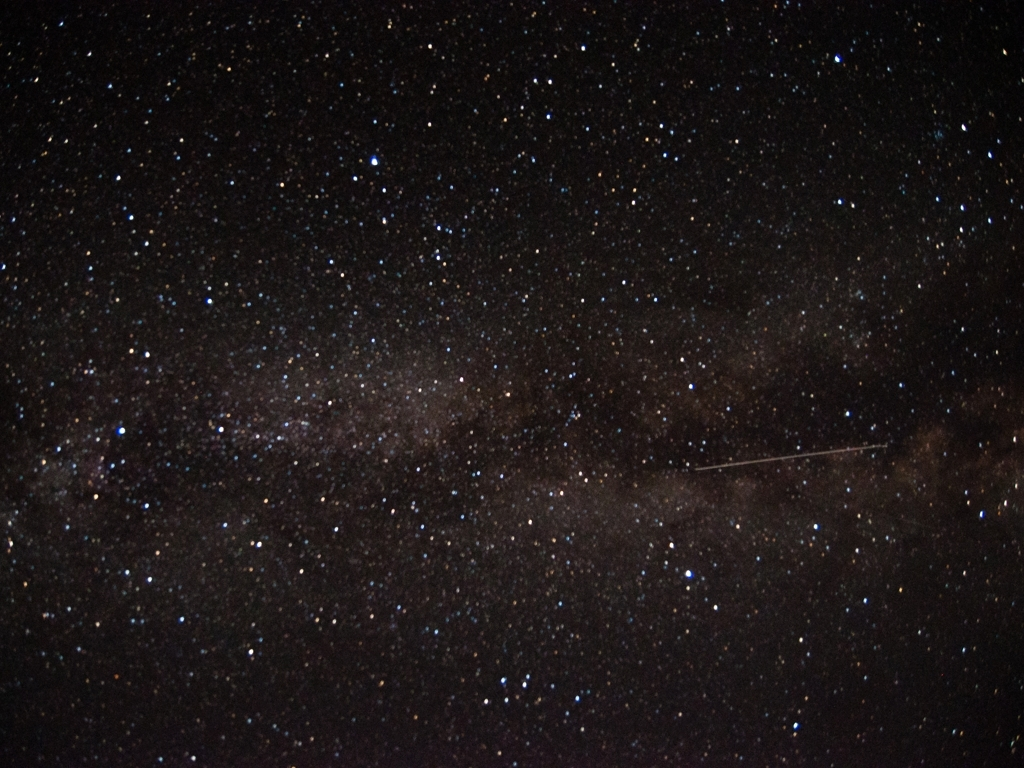Could this image be useful for astronomical studies? Yes, images like this can be incredibly valuable for astronomers. They use such photos to map the distribution of stars and identify celestial features such as star clusters, nebulae, or other galaxies. The variations in star density can lead to insights about the structure of the Milky Way. Furthermore, by tracking objects like the one leaving the streak in the image, astronomers can gather data on meteors or satellites, contributing to our understanding of near-Earth objects. 